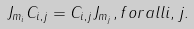<formula> <loc_0><loc_0><loc_500><loc_500>J _ { m _ { i } } C _ { i , j } = C _ { i , j } J _ { m _ { j } } , f o r a l l i , j .</formula> 